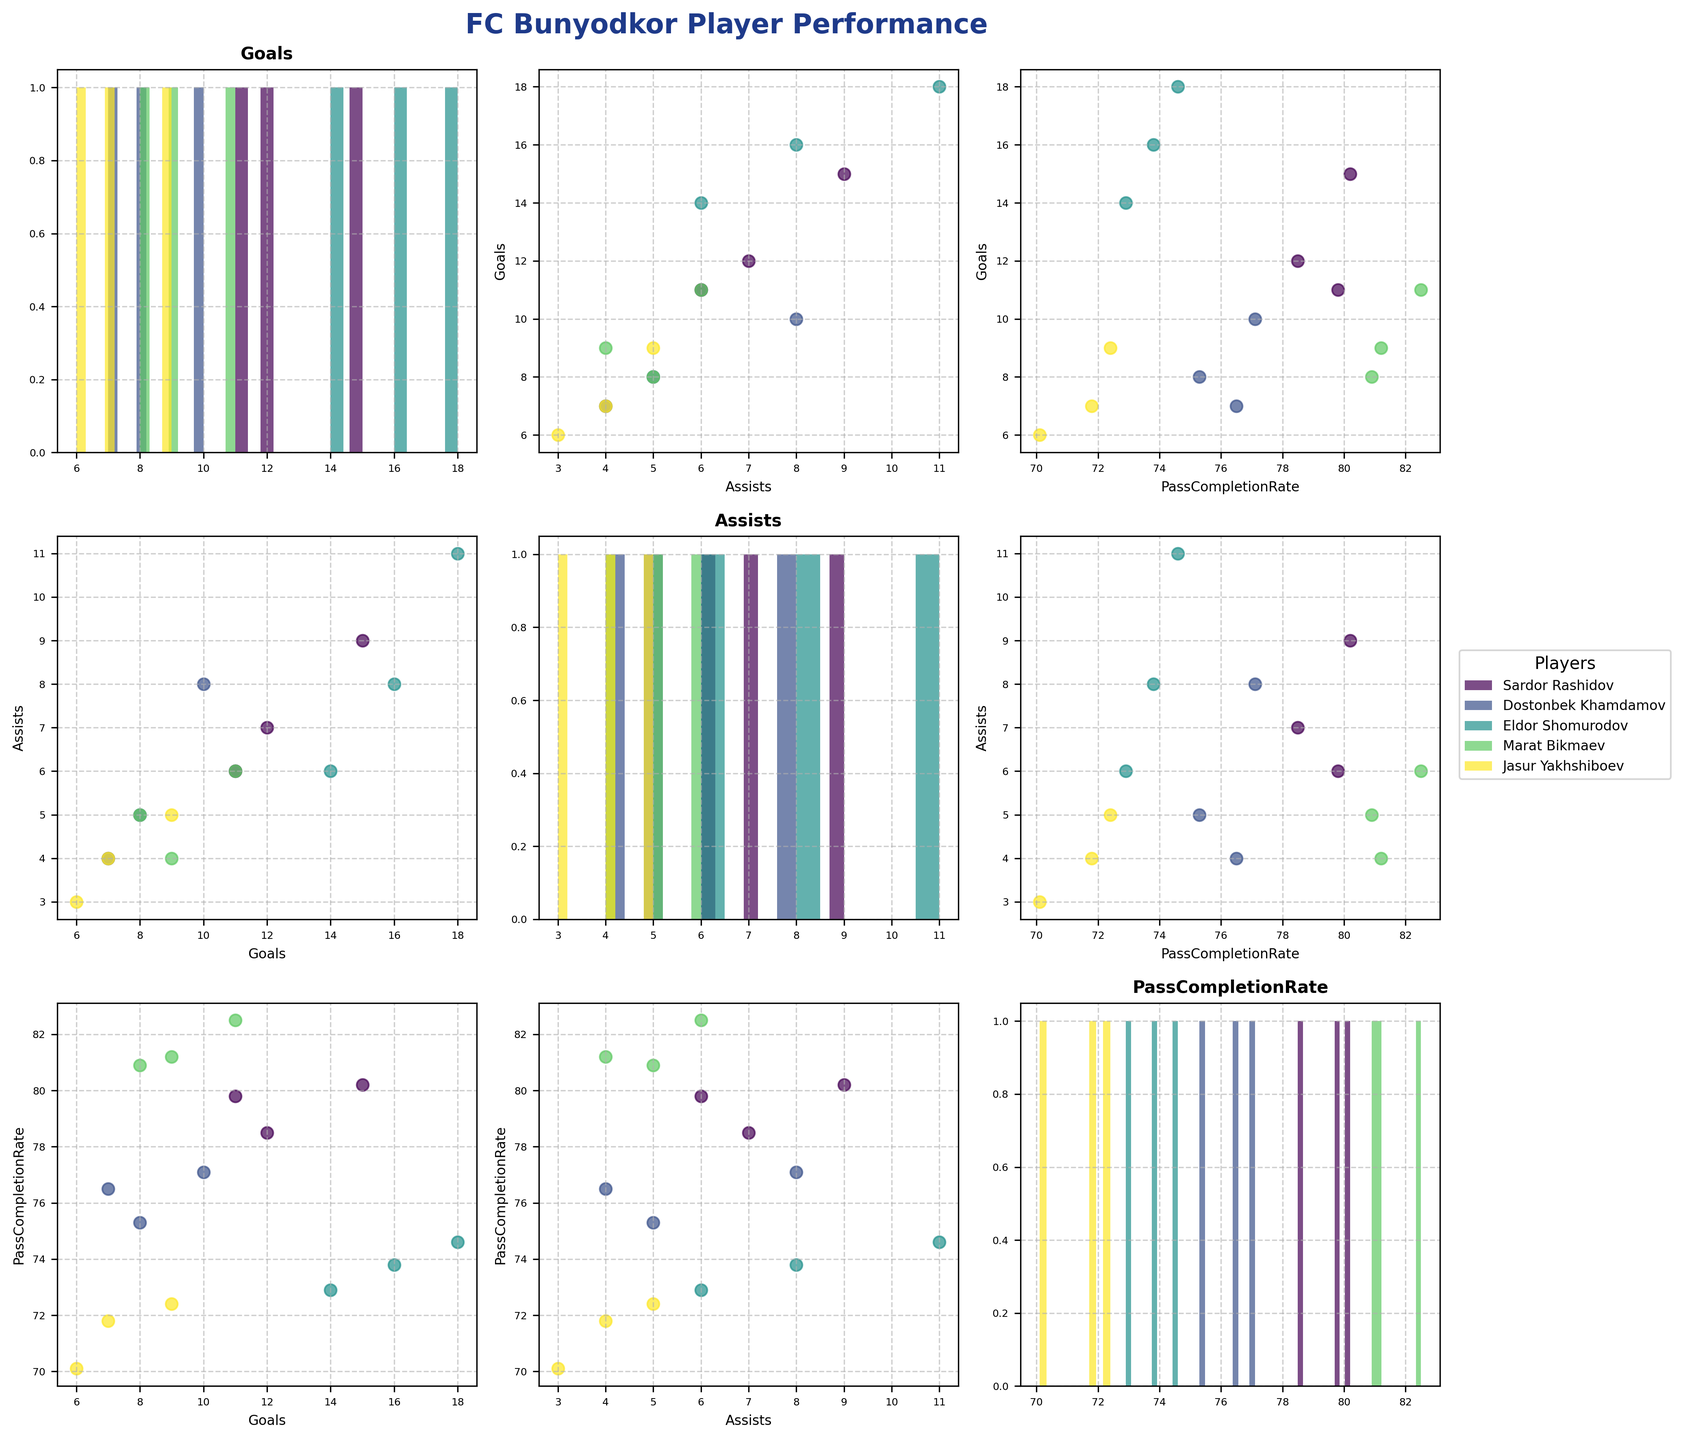Does Eldor Shomurodov have a higher average number of goals or assists over the three seasons? Calculate the average goals and assists Eldor Shomurodov scored each season: Average Goals = (14+18+16)/3 = 16, Average Assists = (6+11+8)/3 ≈ 8.33. So, he has a higher average number of goals.
Answer: Goals Which player has the highest pass completion rate in the 2019 season? Identify pass completion rates for all players in 2019: Sardor Rashidov (80.2), Dostonbek Khamdamov (77.1), Eldor Shomurodov (74.6), Marat Bikmaev (82.5), Jasur Yakhshiboev (72.4). Marat Bikmaev has the highest.
Answer: Marat Bikmaev Do any players have more than 10 goals in all three seasons? Check each player's goals for all seasons: Sardor Rashidov (12, 15, 11), Eldor Shomurodov (14, 18, 16). Both Sardor Rashidov and Eldor Shomurodov have more than 10 goals in all seasons.
Answer: Yes Which metric shows the least variation for any single player—goals, assists, or pass completion rate? Calculate the range (max - min) for each metric per player. The least variation will have the smallest range. E.g., for Sardor: Goals (15-11=4), Assists (9-6=3), PassCompletionRate (80.2-78.5=1.7). Sardor Rashidov's pass completion rate shows the least variation across all metrics.
Answer: PassCompletionRate for Sardor Rashidov How do Sardor Rashidov's goals compare to his assists visually? Examine the scatter plots that compare goals to assists for Sardor Rashidov in the figure. It can be seen visually that his goals generally exceed his assists each season.
Answer: Goals > Assists In which season did Jasur Yakhshiboev have the lowest pass completion rate? Identify Jasur Yakhshiboev's pass completion rates for all seasons: 2018 - 70.1, 2019 - 72.4, 2020 - 71.8. The lowest is in 2018.
Answer: 2018 Which player had the highest number of assists in any season? Check the maximum assists for all players and seasons: Sardor Rashidov (9), Dostonbek Khamdamov (8), Eldor Shomurodov (11), Marat Bikmaev (6), Jasur Yakhshiboev (5). Eldor Shomurodov has the highest number of assists in 2019.
Answer: Eldor Shomurodov Between 2018 and 2019, which player showed the greatest improvement in goals scored? Calculate the difference in goals from 2018 to 2019 for each player: Sardor Rashidov (15-12=3), Dostonbek Khamdamov (10-8=2), Eldor Shomurodov (18-14=4), Marat Bikmaev (11-9=2), Jasur Yakhshiboev (9-6=3). Eldor Shomurodov showed the greatest improvement in goals scored.
Answer: Eldor Shomurodov 